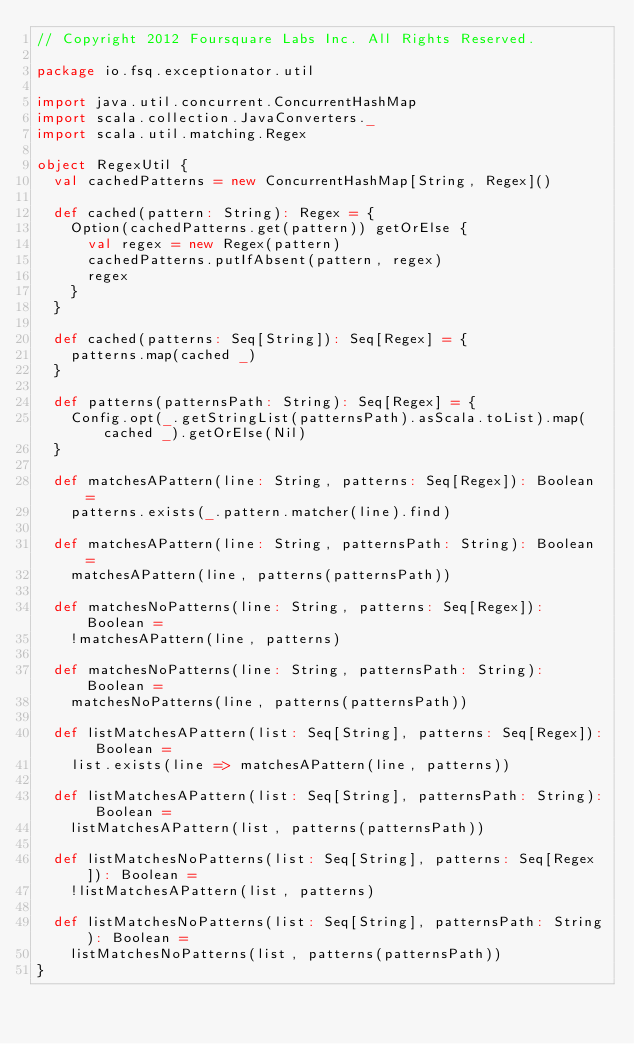Convert code to text. <code><loc_0><loc_0><loc_500><loc_500><_Scala_>// Copyright 2012 Foursquare Labs Inc. All Rights Reserved.

package io.fsq.exceptionator.util

import java.util.concurrent.ConcurrentHashMap
import scala.collection.JavaConverters._
import scala.util.matching.Regex

object RegexUtil {
  val cachedPatterns = new ConcurrentHashMap[String, Regex]()

  def cached(pattern: String): Regex = {
    Option(cachedPatterns.get(pattern)) getOrElse {
      val regex = new Regex(pattern)
      cachedPatterns.putIfAbsent(pattern, regex)
      regex
    }
  }

  def cached(patterns: Seq[String]): Seq[Regex] = {
    patterns.map(cached _)
  }

  def patterns(patternsPath: String): Seq[Regex] = {
    Config.opt(_.getStringList(patternsPath).asScala.toList).map(cached _).getOrElse(Nil)
  }

  def matchesAPattern(line: String, patterns: Seq[Regex]): Boolean =
    patterns.exists(_.pattern.matcher(line).find)

  def matchesAPattern(line: String, patternsPath: String): Boolean =
    matchesAPattern(line, patterns(patternsPath))

  def matchesNoPatterns(line: String, patterns: Seq[Regex]): Boolean =
    !matchesAPattern(line, patterns)

  def matchesNoPatterns(line: String, patternsPath: String): Boolean =
    matchesNoPatterns(line, patterns(patternsPath))

  def listMatchesAPattern(list: Seq[String], patterns: Seq[Regex]): Boolean =
    list.exists(line => matchesAPattern(line, patterns))

  def listMatchesAPattern(list: Seq[String], patternsPath: String): Boolean =
    listMatchesAPattern(list, patterns(patternsPath))

  def listMatchesNoPatterns(list: Seq[String], patterns: Seq[Regex]): Boolean =
    !listMatchesAPattern(list, patterns)

  def listMatchesNoPatterns(list: Seq[String], patternsPath: String): Boolean =
    listMatchesNoPatterns(list, patterns(patternsPath))
}
</code> 